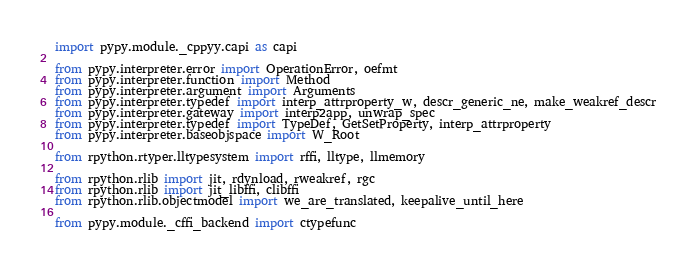<code> <loc_0><loc_0><loc_500><loc_500><_Python_>import pypy.module._cppyy.capi as capi

from pypy.interpreter.error import OperationError, oefmt
from pypy.interpreter.function import Method
from pypy.interpreter.argument import Arguments
from pypy.interpreter.typedef import interp_attrproperty_w, descr_generic_ne, make_weakref_descr
from pypy.interpreter.gateway import interp2app, unwrap_spec
from pypy.interpreter.typedef import TypeDef, GetSetProperty, interp_attrproperty
from pypy.interpreter.baseobjspace import W_Root

from rpython.rtyper.lltypesystem import rffi, lltype, llmemory

from rpython.rlib import jit, rdynload, rweakref, rgc
from rpython.rlib import jit_libffi, clibffi
from rpython.rlib.objectmodel import we_are_translated, keepalive_until_here

from pypy.module._cffi_backend import ctypefunc</code> 